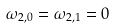Convert formula to latex. <formula><loc_0><loc_0><loc_500><loc_500>\omega _ { 2 , 0 } = \omega _ { 2 , 1 } = 0</formula> 